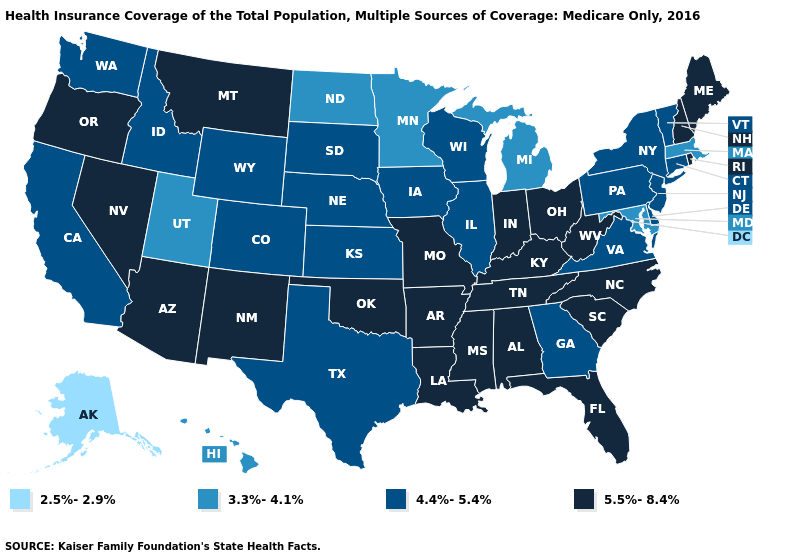How many symbols are there in the legend?
Be succinct. 4. What is the highest value in states that border Montana?
Concise answer only. 4.4%-5.4%. What is the value of Montana?
Be succinct. 5.5%-8.4%. Does New Mexico have the same value as Wyoming?
Be succinct. No. What is the highest value in the USA?
Keep it brief. 5.5%-8.4%. Name the states that have a value in the range 3.3%-4.1%?
Short answer required. Hawaii, Maryland, Massachusetts, Michigan, Minnesota, North Dakota, Utah. What is the value of South Dakota?
Give a very brief answer. 4.4%-5.4%. Does New Hampshire have the highest value in the USA?
Be succinct. Yes. Among the states that border Florida , which have the highest value?
Give a very brief answer. Alabama. Does Idaho have the lowest value in the USA?
Keep it brief. No. Name the states that have a value in the range 4.4%-5.4%?
Be succinct. California, Colorado, Connecticut, Delaware, Georgia, Idaho, Illinois, Iowa, Kansas, Nebraska, New Jersey, New York, Pennsylvania, South Dakota, Texas, Vermont, Virginia, Washington, Wisconsin, Wyoming. Name the states that have a value in the range 2.5%-2.9%?
Short answer required. Alaska. What is the value of Mississippi?
Keep it brief. 5.5%-8.4%. Among the states that border Massachusetts , does Vermont have the lowest value?
Short answer required. Yes. What is the value of Montana?
Write a very short answer. 5.5%-8.4%. 